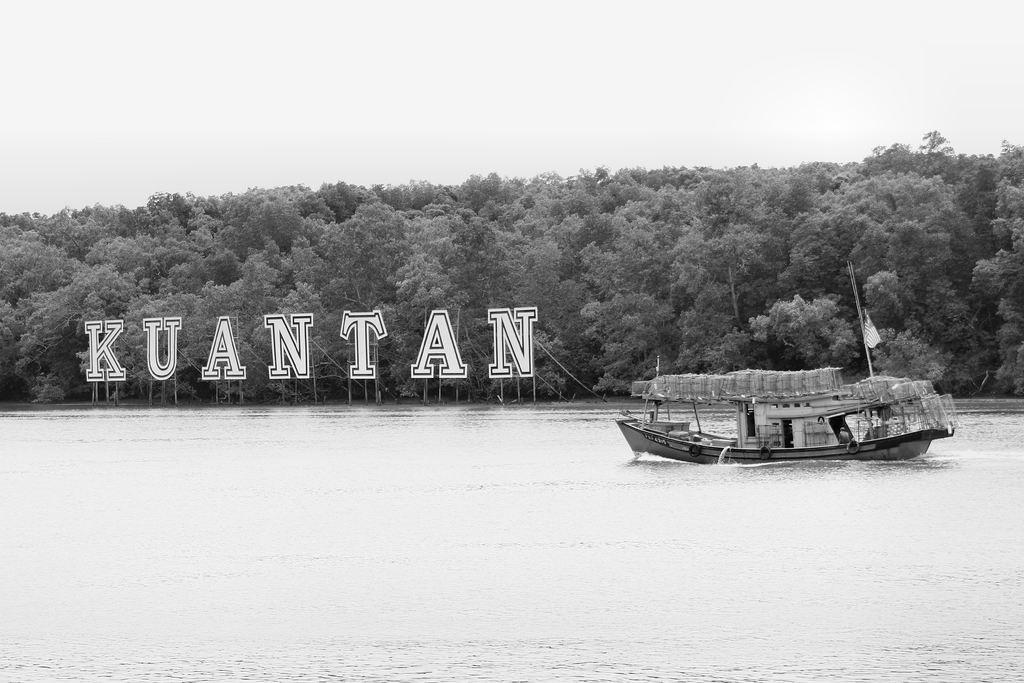What is the main subject of the image? The main subject of the image is a boat. What is the boat doing in the image? The boat is sailing on the water. What other objects can be seen in the image? There are alphabet boards visible in the image. Where are the alphabet boards located in relation to the water? The alphabet boards are behind the water. What can be seen in the background of the image? There are trees visible in the background of the image. How many tomatoes are hanging from the trees in the image? There are no tomatoes visible in the image; only trees can be seen in the background. Can you tell me if there is a deer hiding behind the alphabet boards? There is no deer present in the image; only the boat, water, alphabet boards, and trees are visible. 